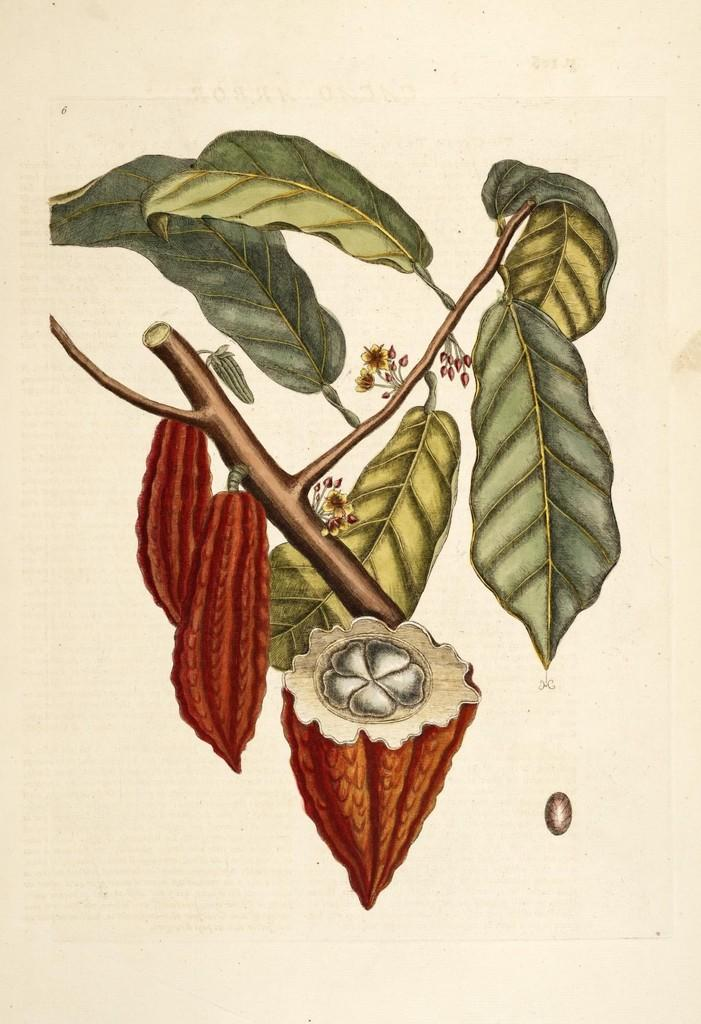What is depicted in the image? There is a picture of fruits in the image. Are there any other elements related to plants in the image? Yes, there are leaves in the image. Can you describe the leaves' location in the image? The leaves are on the stem of a plant. How many cans of soda are placed on the chairs in the image? There are no cans of soda or chairs present in the image. 